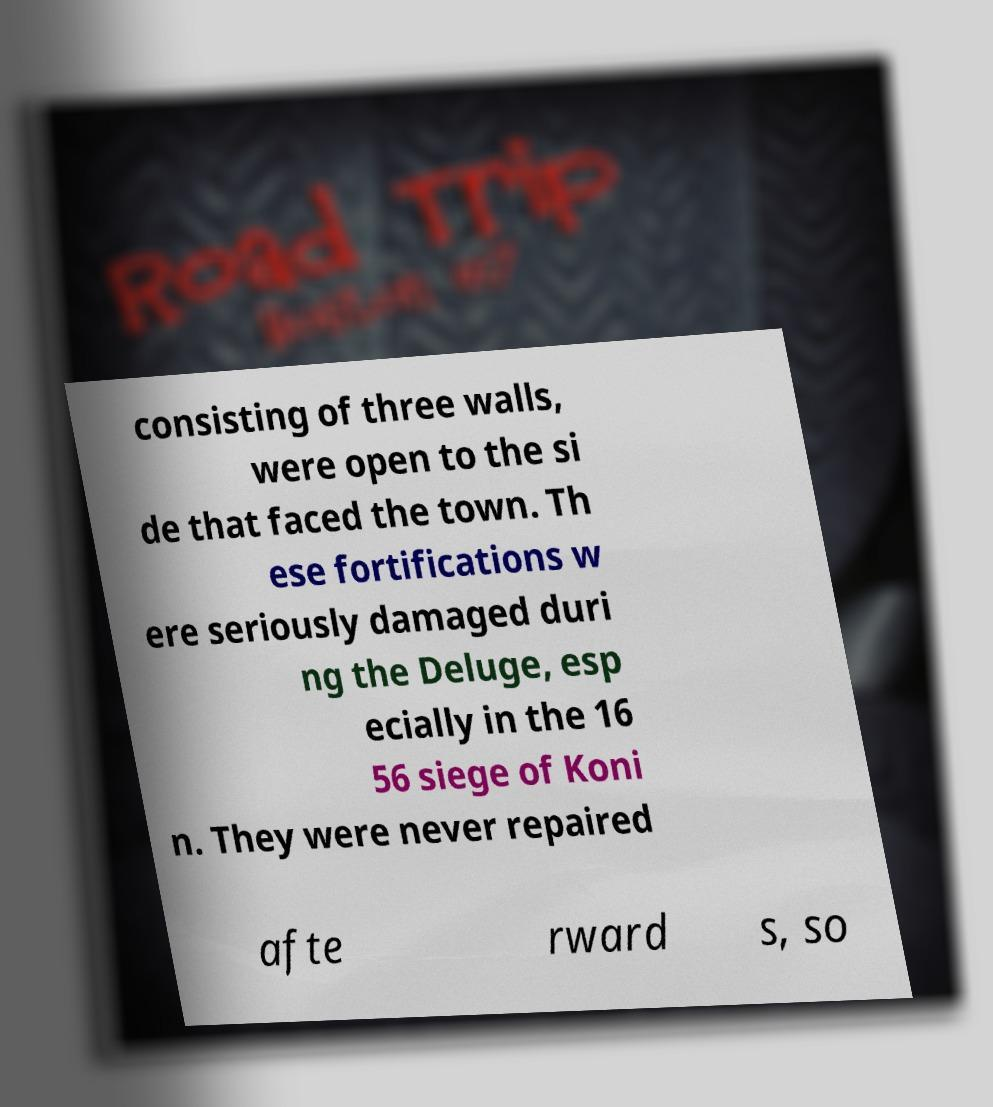Can you accurately transcribe the text from the provided image for me? consisting of three walls, were open to the si de that faced the town. Th ese fortifications w ere seriously damaged duri ng the Deluge, esp ecially in the 16 56 siege of Koni n. They were never repaired afte rward s, so 